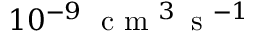Convert formula to latex. <formula><loc_0><loc_0><loc_500><loc_500>1 0 ^ { - 9 } \, { c m ^ { 3 } \, s ^ { - 1 } }</formula> 